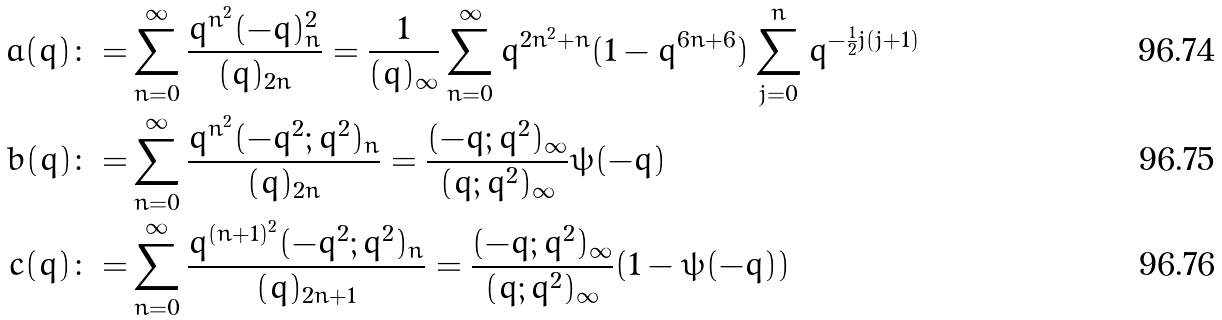Convert formula to latex. <formula><loc_0><loc_0><loc_500><loc_500>a ( q ) \colon = & \sum _ { n = 0 } ^ { \infty } \frac { q ^ { n ^ { 2 } } ( - q ) _ { n } ^ { 2 } } { ( q ) _ { 2 n } } = \frac { 1 } { ( q ) _ { \infty } } \sum _ { n = 0 } ^ { \infty } q ^ { 2 n ^ { 2 } + n } ( 1 - q ^ { 6 n + 6 } ) \sum _ { j = 0 } ^ { n } q ^ { - \frac { 1 } { 2 } j ( j + 1 ) } \\ b ( q ) \colon = & \sum _ { n = 0 } ^ { \infty } \frac { q ^ { n ^ { 2 } } ( - q ^ { 2 } ; q ^ { 2 } ) _ { n } } { ( q ) _ { 2 n } } = \frac { ( - q ; q ^ { 2 } ) _ { \infty } } { ( q ; q ^ { 2 } ) _ { \infty } } \psi ( - q ) \\ c ( q ) \colon = & \sum _ { n = 0 } ^ { \infty } \frac { q ^ { ( n + 1 ) ^ { 2 } } ( - q ^ { 2 } ; q ^ { 2 } ) _ { n } } { ( q ) _ { 2 n + 1 } } = \frac { ( - q ; q ^ { 2 } ) _ { \infty } } { ( q ; q ^ { 2 } ) _ { \infty } } ( 1 - \psi ( - q ) )</formula> 